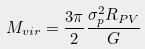<formula> <loc_0><loc_0><loc_500><loc_500>M _ { v i r } = \frac { 3 \pi } { 2 } \frac { \sigma _ { p } ^ { 2 } R _ { P V } } { G }</formula> 